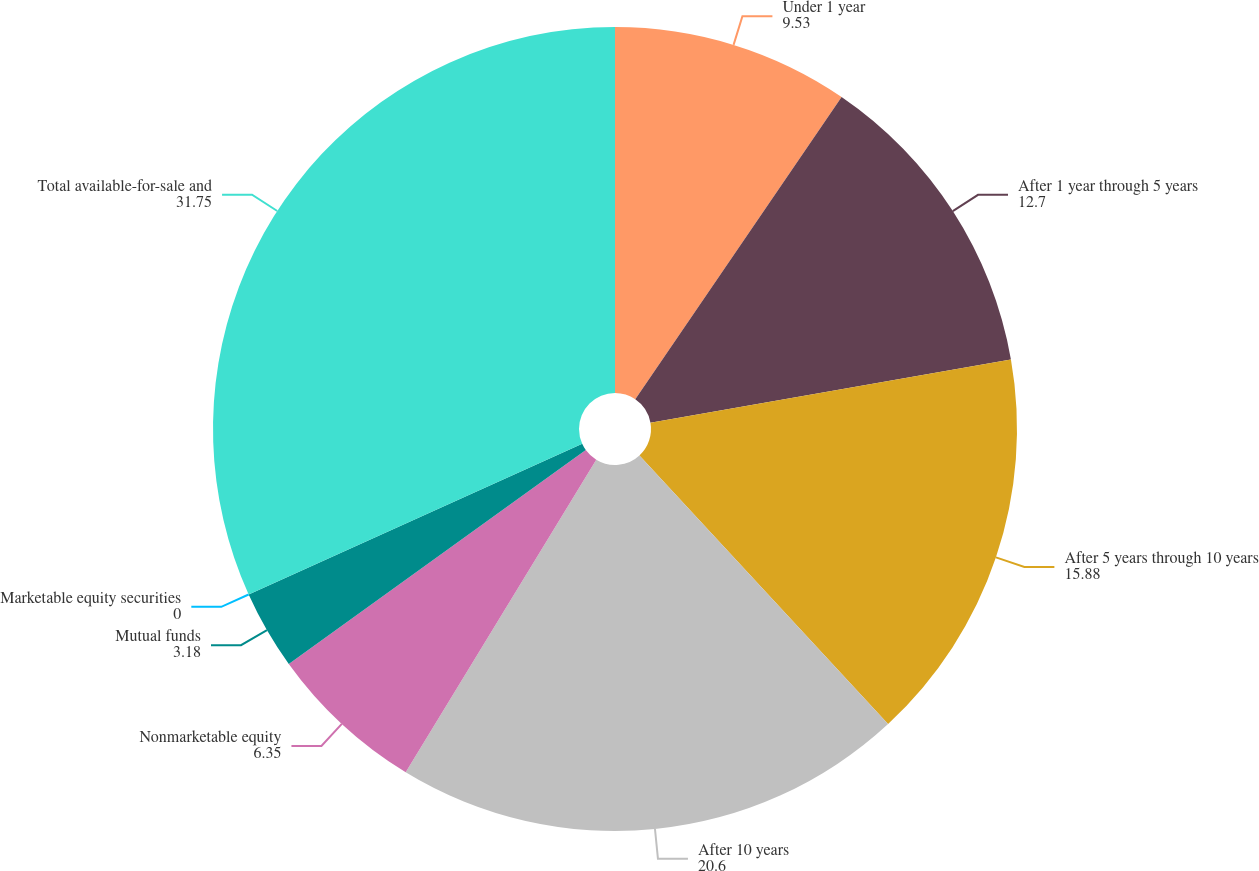Convert chart to OTSL. <chart><loc_0><loc_0><loc_500><loc_500><pie_chart><fcel>Under 1 year<fcel>After 1 year through 5 years<fcel>After 5 years through 10 years<fcel>After 10 years<fcel>Nonmarketable equity<fcel>Mutual funds<fcel>Marketable equity securities<fcel>Total available-for-sale and<nl><fcel>9.53%<fcel>12.7%<fcel>15.88%<fcel>20.6%<fcel>6.35%<fcel>3.18%<fcel>0.0%<fcel>31.75%<nl></chart> 